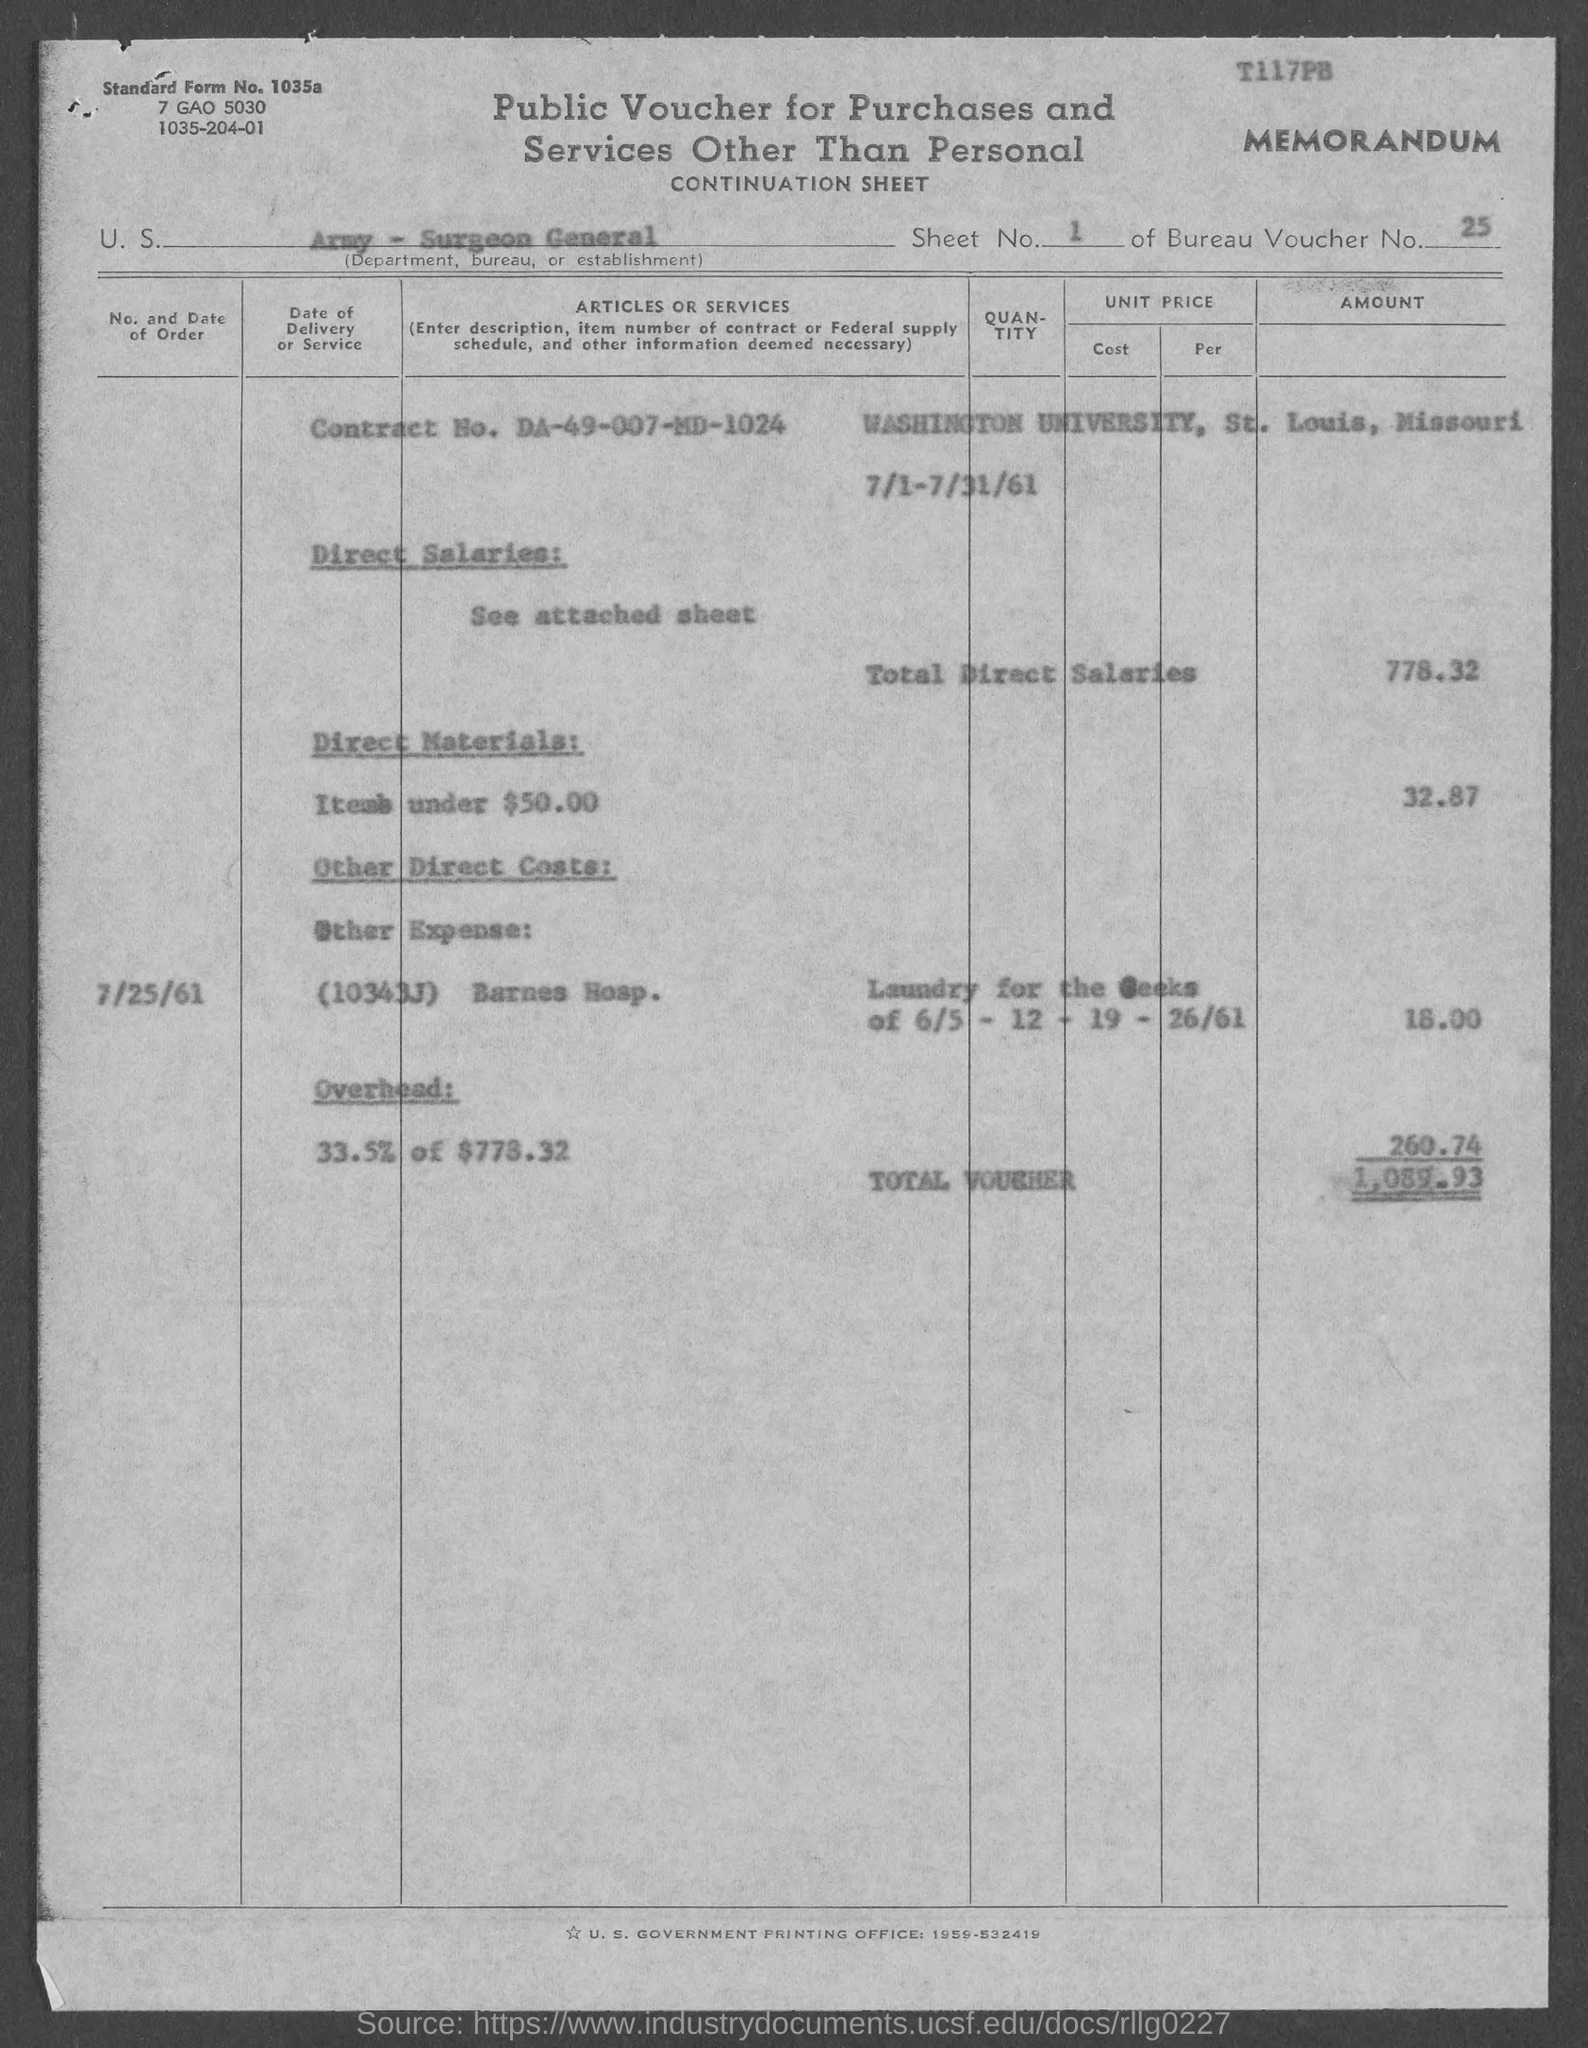Outline some significant characteristics in this image. The sheet number mentioned in the given form is 1. The date mentioned in the given page is July 25th, 1961. The amount of direct materials mentioned on the given page is 32.87. The contract number mentioned in the given form is DA-49-007-MD-1024. The total value of the voucher mentioned in the given form is 1,089.93. 